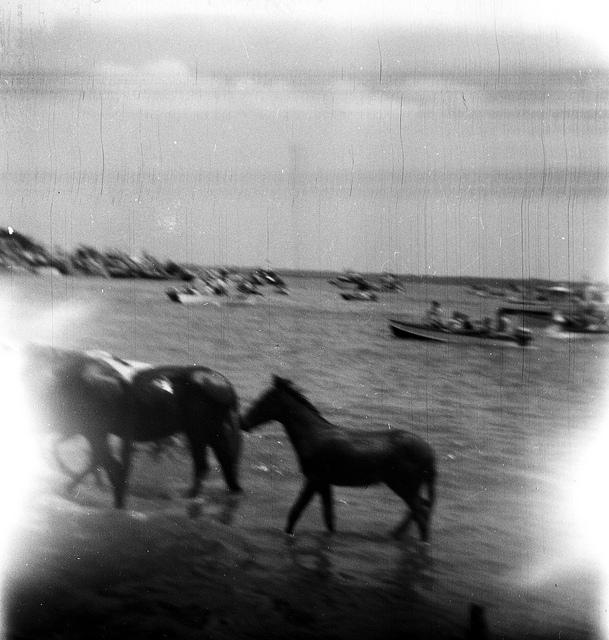What is on the water?
Answer briefly. Boats. Is the ground wet?
Short answer required. Yes. Is this a good quality photo?
Quick response, please. No. How many horses are in the photo?
Write a very short answer. 3. 